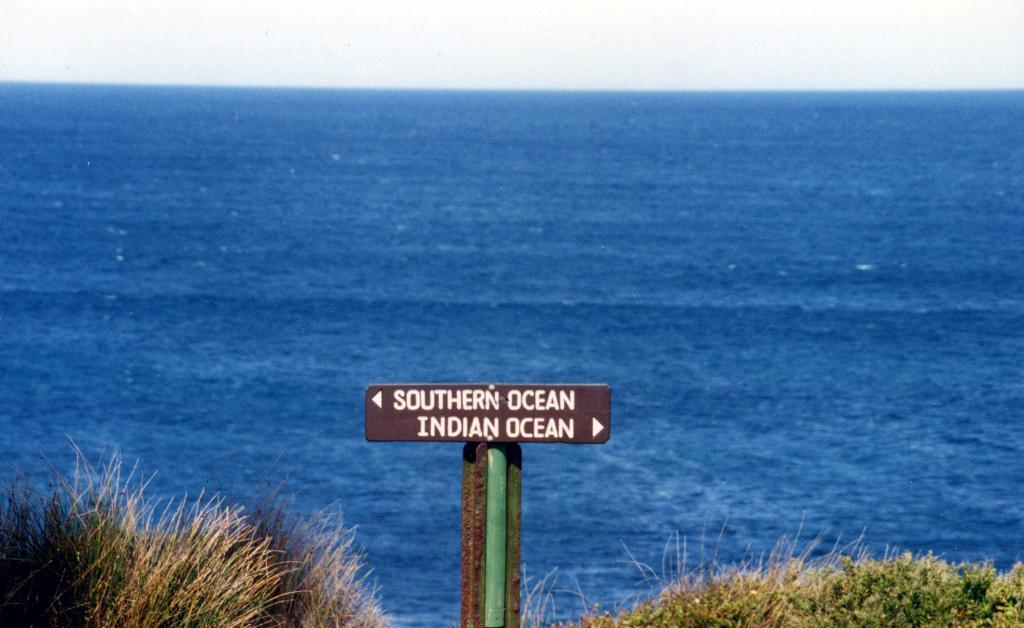What is the main object in the image? There is a board in the image. What information is displayed on the board? The board has "Southern Ocean" and "Indian Ocean" written on it. What can be seen in the background of the image? There is water visible in the background of the image. Where is the ant located in the image? There is no ant present in the image. What is the mouth of the person in the image doing? There is no person present in the image. 